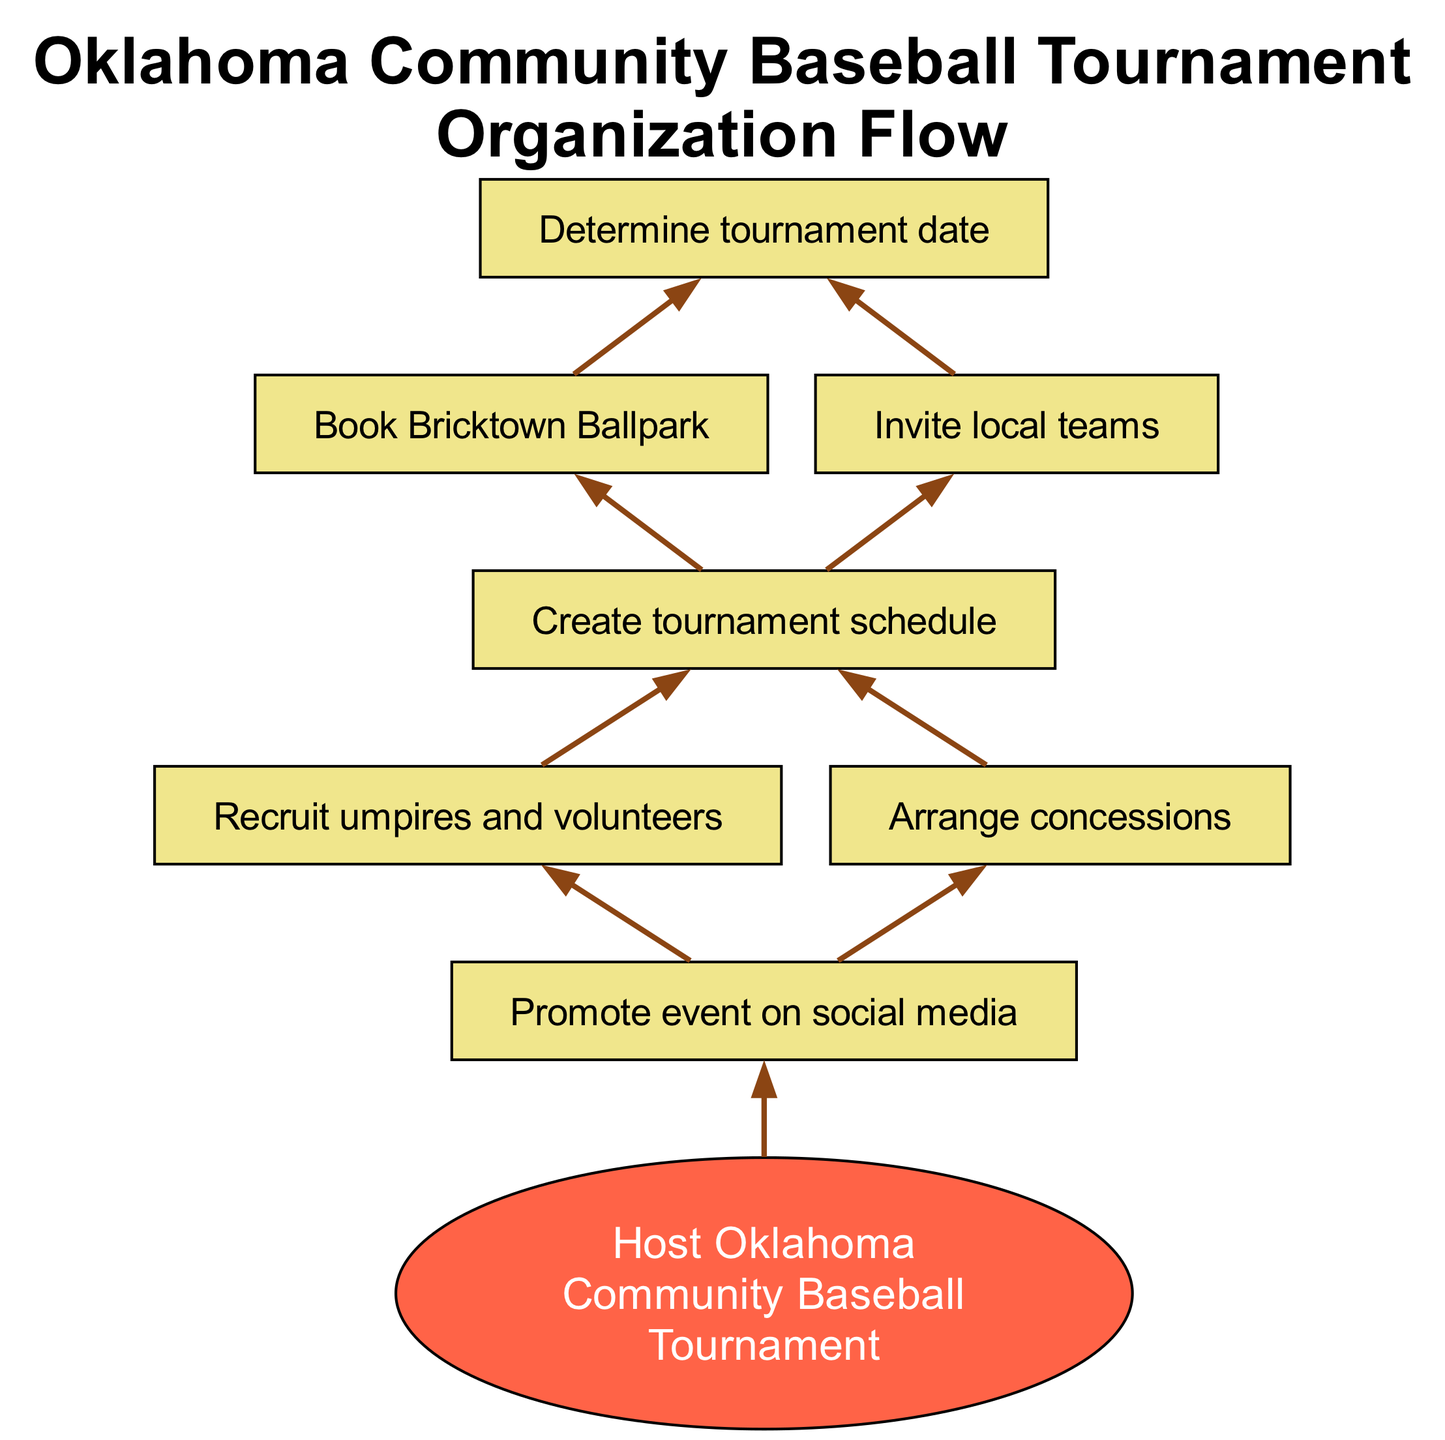What is the first step in organizing the tournament? The first step listed in the diagram is to determine the tournament date. This is the starting point before any other tasks can be planned or executed.
Answer: Determine tournament date How many main steps are shown in the flowchart? By counting the number of unique elements in the diagram, we can see there are 8 distinct steps that lead to hosting the tournament.
Answer: 8 What is the last step in the tournament organization process? The last step indicated in the diagram is to host the Oklahoma community baseball tournament, which concludes the entire process.
Answer: Host Oklahoma community baseball tournament Which step involves inviting participants? The step that specifically involves inviting participants is labeled as "Invite local teams," which directly references engaging teams for the tournament.
Answer: Invite local teams What follows after creating the tournament schedule? After creating the tournament schedule, the next steps involve recruiting umpires and volunteers, as well as arranging concessions, showing that both are parallel tasks following this key step.
Answer: Recruit umpires and volunteers, Arrange concessions What location is specified for the tournament? The diagram specifies Bricktown Ballpark as the location for the tournament, indicating where the event will take place.
Answer: Bricktown Ballpark What is the purpose of promoting the event on social media? The purpose of promoting the event on social media, as indicated in the diagram, is to increase awareness and participation in the tournament.
Answer: Increase awareness and participation What is indicated as necessary for running the tournament effectively? Recruiting umpires and volunteers is indicated as a necessary step for running the tournament effectively, as they are essential for managing the games.
Answer: Recruit umpires and volunteers 